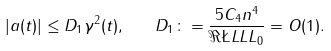<formula> <loc_0><loc_0><loc_500><loc_500>| a ( t ) | \leq D _ { 1 } \gamma ^ { 2 } ( t ) , \quad D _ { 1 } \colon = \frac { 5 C _ { 4 } n ^ { 4 } } { \Re \L L L L _ { 0 } } = O ( 1 ) .</formula> 